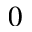Convert formula to latex. <formula><loc_0><loc_0><loc_500><loc_500>0</formula> 